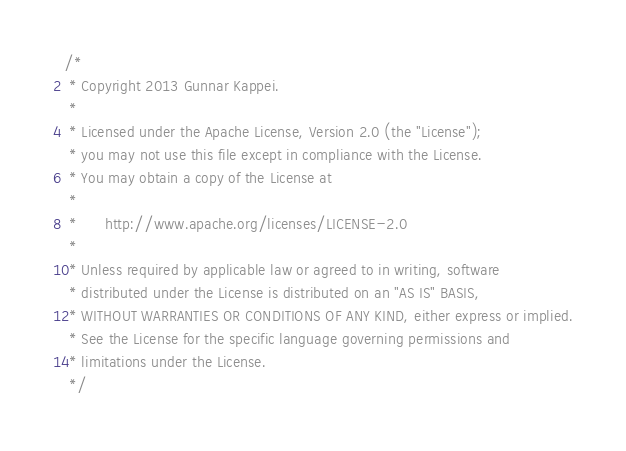<code> <loc_0><loc_0><loc_500><loc_500><_Java_>/* 
 * Copyright 2013 Gunnar Kappei.
 *
 * Licensed under the Apache License, Version 2.0 (the "License");
 * you may not use this file except in compliance with the License.
 * You may obtain a copy of the License at
 *
 *      http://www.apache.org/licenses/LICENSE-2.0
 *
 * Unless required by applicable law or agreed to in writing, software
 * distributed under the License is distributed on an "AS IS" BASIS,
 * WITHOUT WARRANTIES OR CONDITIONS OF ANY KIND, either express or implied.
 * See the License for the specific language governing permissions and
 * limitations under the License.
 */</code> 